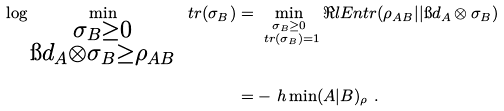<formula> <loc_0><loc_0><loc_500><loc_500>\log \min _ { \substack { \sigma _ { B } \geq 0 \\ \i d _ { A } \otimes \sigma _ { B } \geq \rho _ { A B } } } \ t r ( \sigma _ { B } ) & = \min _ { \substack { \sigma _ { B } \geq 0 \\ \ t r ( \sigma _ { B } ) = 1 } } \Re l E n t r ( \rho _ { A B } | | \i d _ { A } \otimes \sigma _ { B } ) \\ & = - \ h \min ( A | B ) _ { \rho } \ .</formula> 